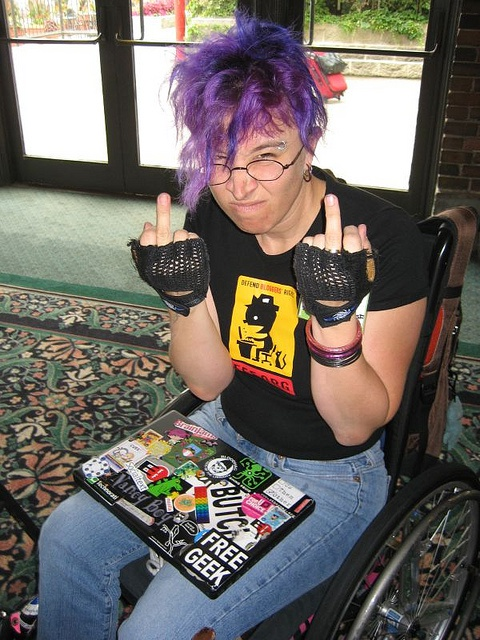Describe the objects in this image and their specific colors. I can see people in black, gray, and tan tones, laptop in black, lightgray, gray, and darkgray tones, chair in black, maroon, and gray tones, and suitcase in black, salmon, brown, and white tones in this image. 